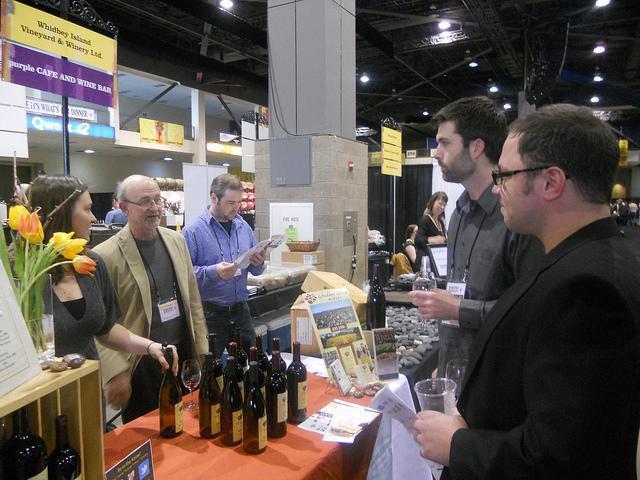How many bottles are in the photo?
Give a very brief answer. 2. How many people are visible?
Give a very brief answer. 5. 